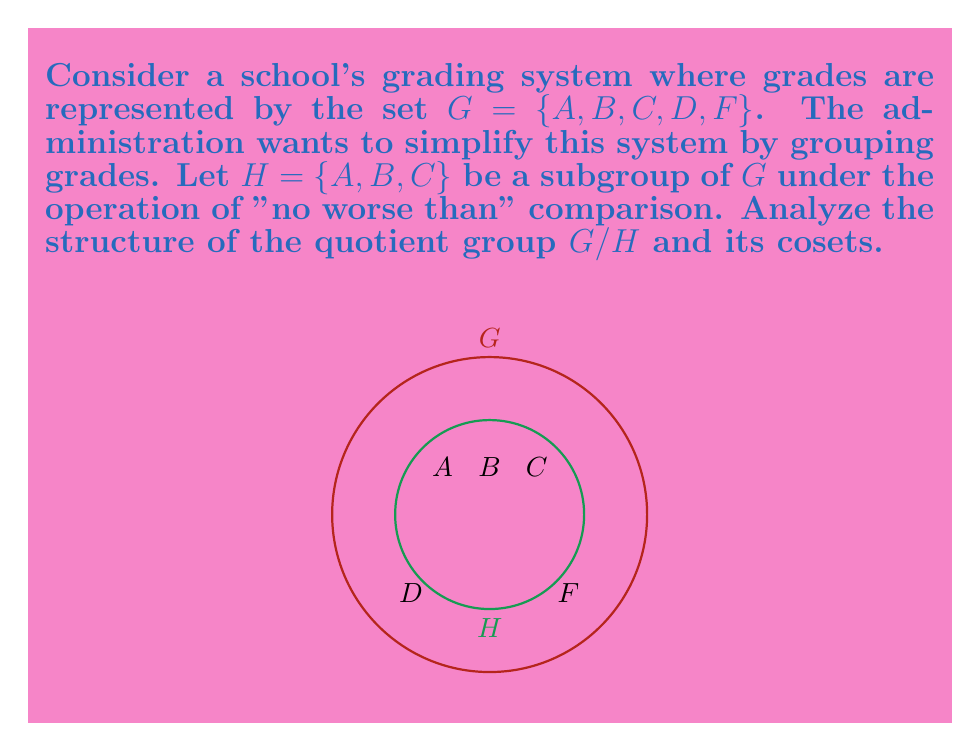Show me your answer to this math problem. To analyze the structure of the quotient group $G/H$ and its cosets, we follow these steps:

1) First, we need to identify the cosets of $H$ in $G$:
   $H = \{A, B, C\}$
   $D + H = \{D\}$
   $F + H = \{F\}$

2) The quotient group $G/H$ consists of these cosets:
   $G/H = \{H, D+H, F+H\}$

3) We can represent this quotient group as:
   $G/H = \{\text{[Pass]}, \text{[D]}, \text{[F]}\}$
   where [Pass] represents grades A, B, and C collectively.

4) The structure of $G/H$ is isomorphic to the cyclic group $\mathbb{Z}_3$, where:
   [Pass] corresponds to 0
   [D] corresponds to 1
   [F] corresponds to 2

5) The operation in this group is "addition modulo 3" which represents moving to the next lower grade category.

6) The order of the quotient group $|G/H| = 3$, which is indeed equal to $|G|/|H| = 5/3$.

7) This quotient group effectively simplifies the grading system into three categories: Pass, D, and F, which could be useful for summarizing overall student performance while maintaining some level of grade privacy.
Answer: $G/H \cong \mathbb{Z}_3$ 